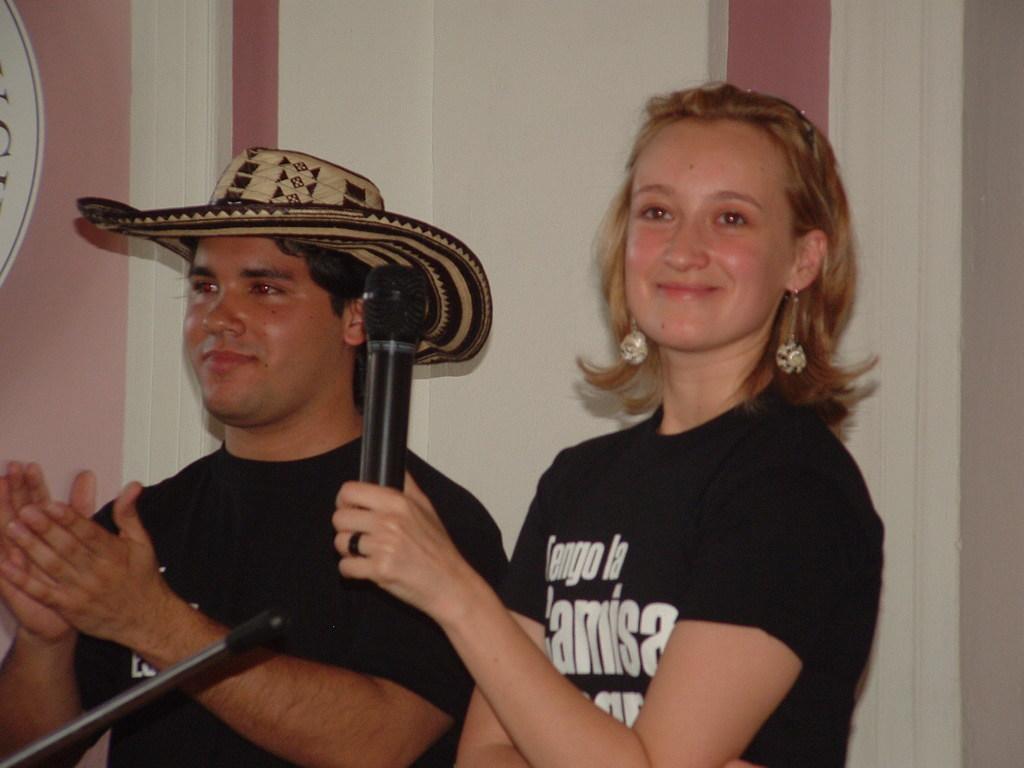Could you give a brief overview of what you see in this image? In this image I see a man and a woman and I see that both of them are smiling and I see that this man is wearing a hat and I see that this woman is holding a mic and I see that both of them are wearing black t-shirts and in the background I see the wall which is of white and pink in color. 